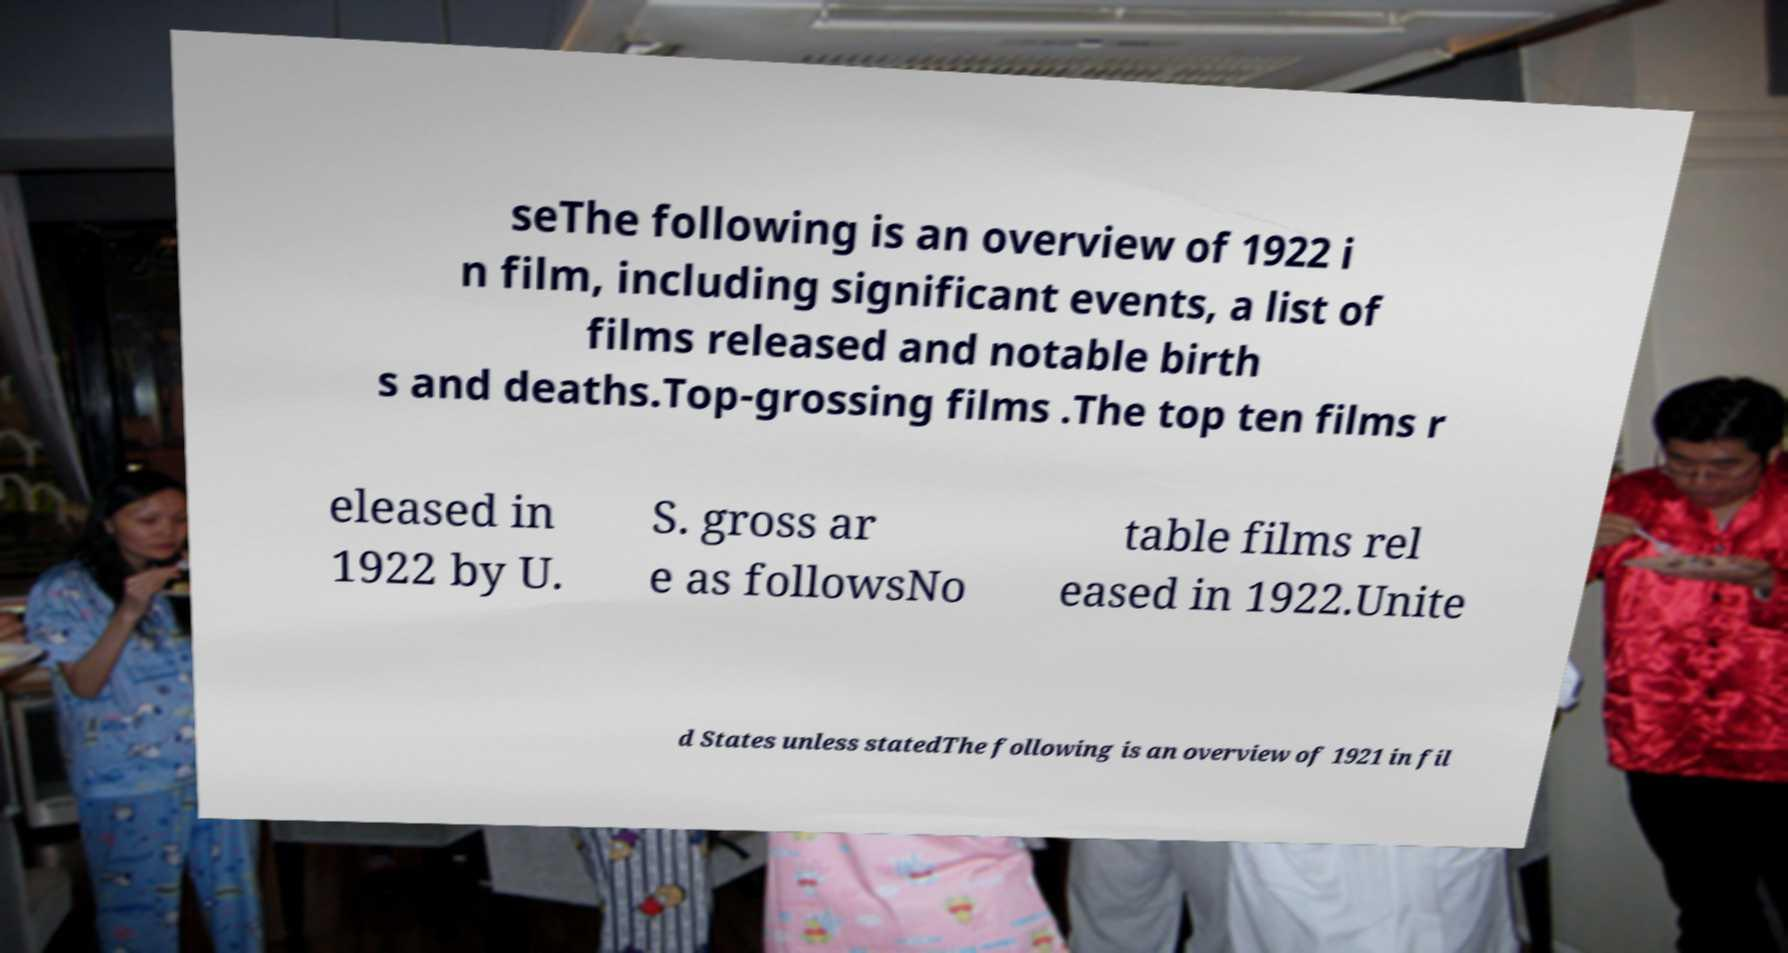I need the written content from this picture converted into text. Can you do that? seThe following is an overview of 1922 i n film, including significant events, a list of films released and notable birth s and deaths.Top-grossing films .The top ten films r eleased in 1922 by U. S. gross ar e as followsNo table films rel eased in 1922.Unite d States unless statedThe following is an overview of 1921 in fil 